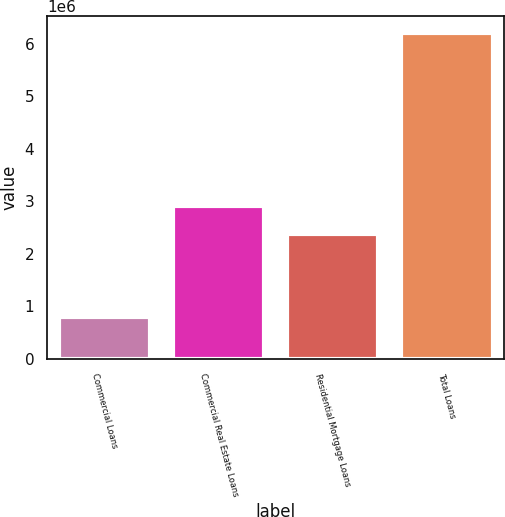<chart> <loc_0><loc_0><loc_500><loc_500><bar_chart><fcel>Commercial Loans<fcel>Commercial Real Estate Loans<fcel>Residential Mortgage Loans<fcel>Total Loans<nl><fcel>801946<fcel>2.9114e+06<fcel>2.37103e+06<fcel>6.20564e+06<nl></chart> 